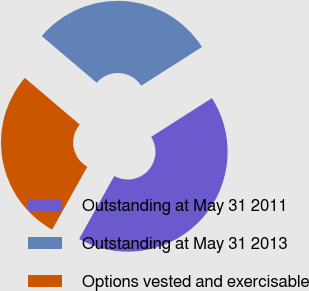Convert chart. <chart><loc_0><loc_0><loc_500><loc_500><pie_chart><fcel>Outstanding at May 31 2011<fcel>Outstanding at May 31 2013<fcel>Options vested and exercisable<nl><fcel>42.15%<fcel>29.75%<fcel>28.1%<nl></chart> 